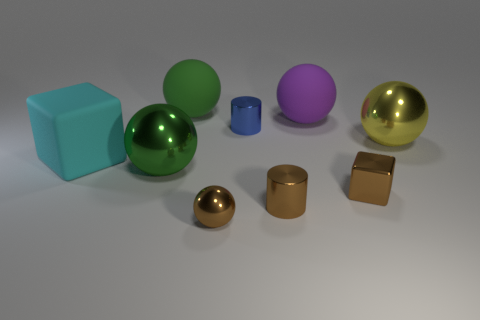Subtract all brown spheres. How many spheres are left? 4 Subtract all purple spheres. How many spheres are left? 4 Subtract 1 balls. How many balls are left? 4 Subtract all blue spheres. Subtract all green cubes. How many spheres are left? 5 Add 1 tiny brown metal cylinders. How many objects exist? 10 Subtract all cylinders. How many objects are left? 7 Subtract 0 green cylinders. How many objects are left? 9 Subtract all blue metal objects. Subtract all yellow things. How many objects are left? 7 Add 3 large objects. How many large objects are left? 8 Add 5 blue rubber spheres. How many blue rubber spheres exist? 5 